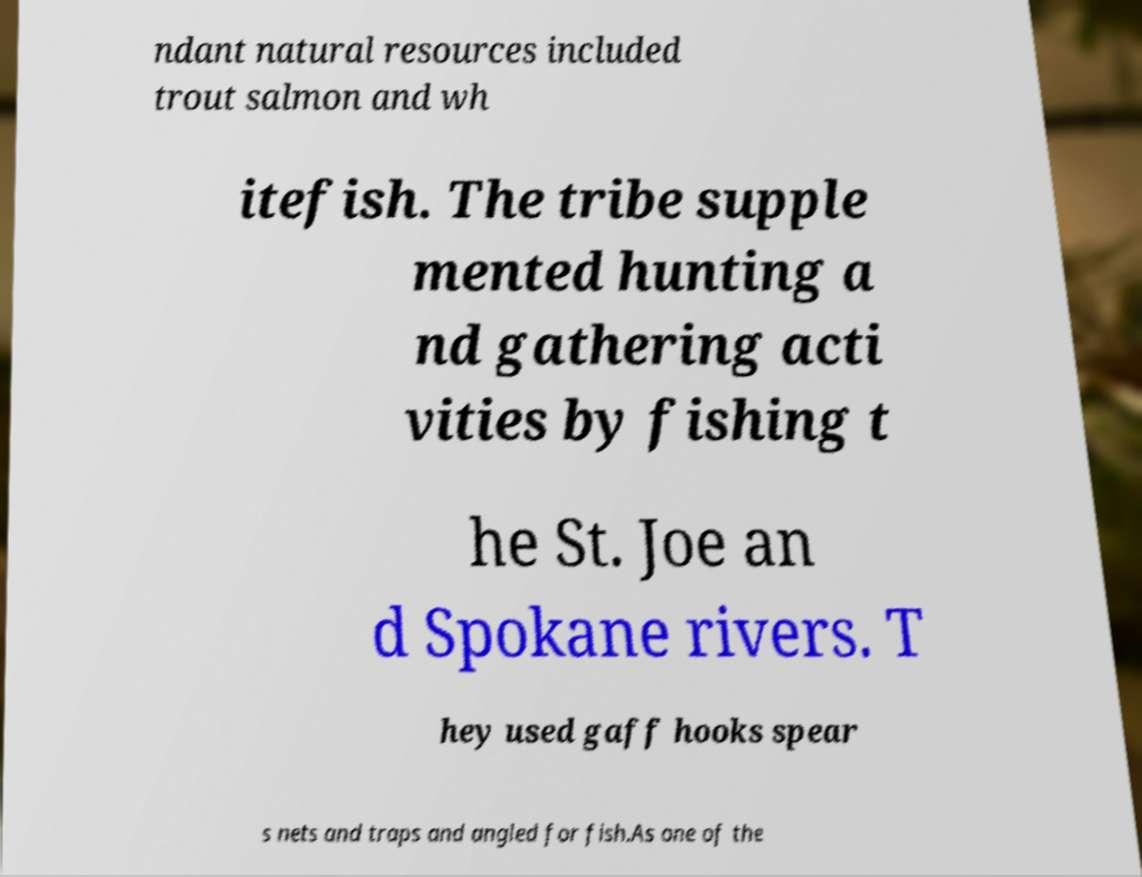For documentation purposes, I need the text within this image transcribed. Could you provide that? ndant natural resources included trout salmon and wh itefish. The tribe supple mented hunting a nd gathering acti vities by fishing t he St. Joe an d Spokane rivers. T hey used gaff hooks spear s nets and traps and angled for fish.As one of the 